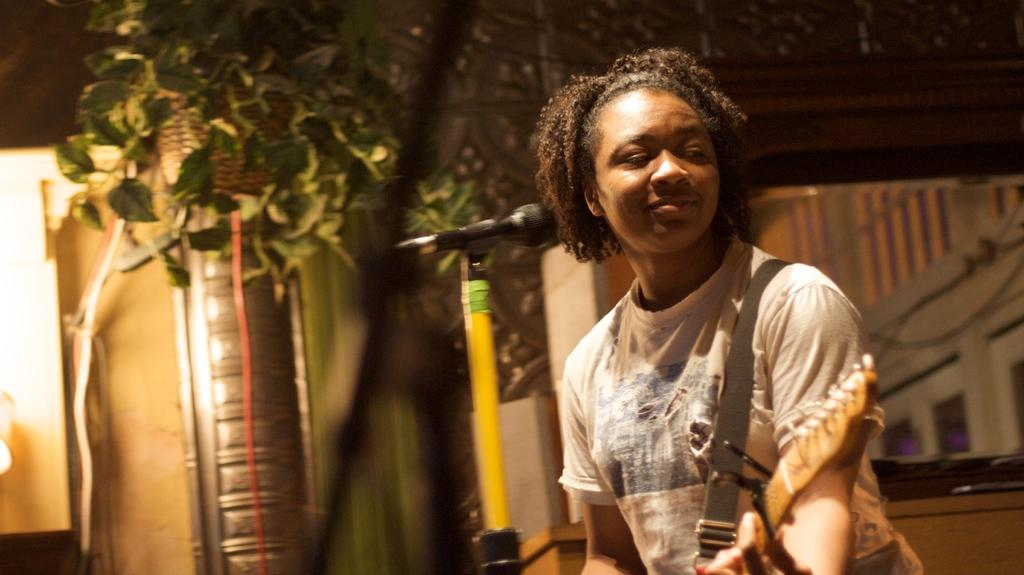Who is the main subject in the image? There is a woman in the image. What is the woman wearing? The woman is wearing a guitar. What is in front of the woman? There is a microphone in front of the woman. How is the microphone positioned? The microphone is attached to a microphone stand. What can be seen in the background of the image? There are houses and a tree in the background of the image. How many pizzas are being served on the table in the image? There are no pizzas present in the image; it features a woman with a guitar, a microphone, and a microphone stand. What question is the woman answering in the image? There is no indication in the image that the woman is answering a question. 